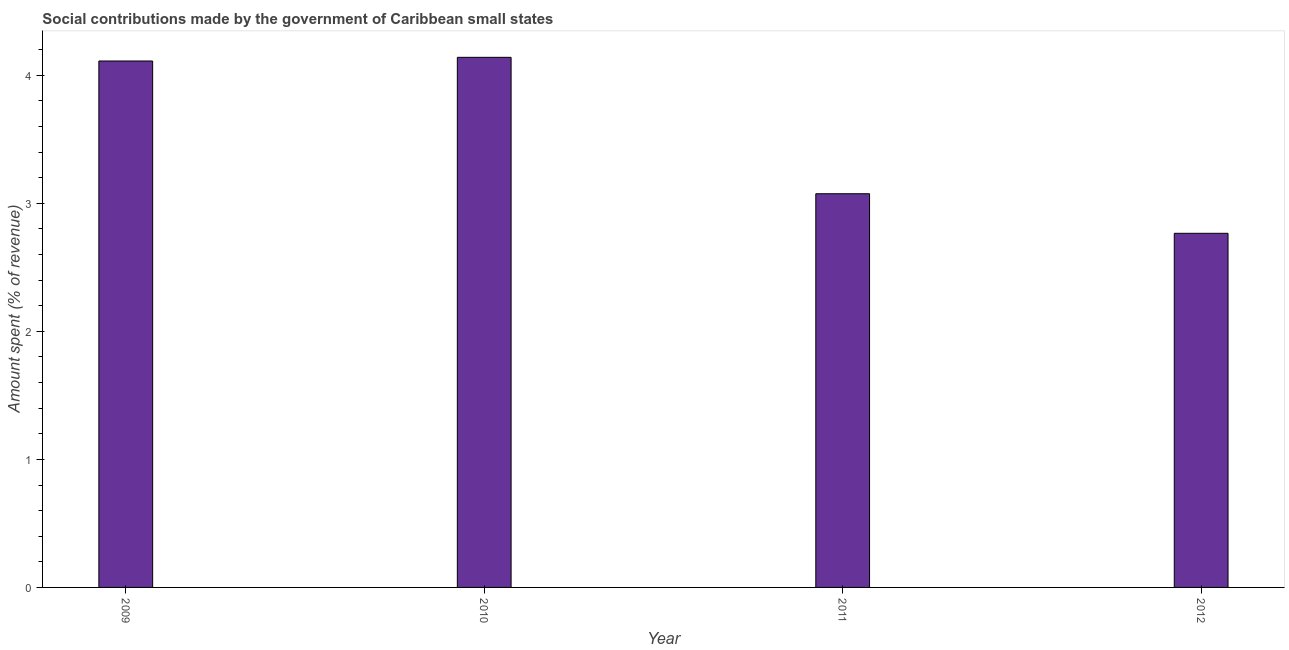Does the graph contain any zero values?
Provide a short and direct response. No. What is the title of the graph?
Ensure brevity in your answer.  Social contributions made by the government of Caribbean small states. What is the label or title of the Y-axis?
Give a very brief answer. Amount spent (% of revenue). What is the amount spent in making social contributions in 2009?
Your response must be concise. 4.11. Across all years, what is the maximum amount spent in making social contributions?
Keep it short and to the point. 4.14. Across all years, what is the minimum amount spent in making social contributions?
Offer a terse response. 2.77. In which year was the amount spent in making social contributions minimum?
Your answer should be very brief. 2012. What is the sum of the amount spent in making social contributions?
Keep it short and to the point. 14.09. What is the difference between the amount spent in making social contributions in 2009 and 2012?
Your answer should be compact. 1.35. What is the average amount spent in making social contributions per year?
Make the answer very short. 3.52. What is the median amount spent in making social contributions?
Provide a succinct answer. 3.59. In how many years, is the amount spent in making social contributions greater than 3.8 %?
Keep it short and to the point. 2. Do a majority of the years between 2011 and 2010 (inclusive) have amount spent in making social contributions greater than 1.4 %?
Make the answer very short. No. What is the ratio of the amount spent in making social contributions in 2011 to that in 2012?
Provide a succinct answer. 1.11. What is the difference between the highest and the second highest amount spent in making social contributions?
Offer a terse response. 0.03. What is the difference between the highest and the lowest amount spent in making social contributions?
Your answer should be very brief. 1.37. How many bars are there?
Offer a very short reply. 4. How many years are there in the graph?
Make the answer very short. 4. What is the difference between two consecutive major ticks on the Y-axis?
Provide a short and direct response. 1. Are the values on the major ticks of Y-axis written in scientific E-notation?
Your response must be concise. No. What is the Amount spent (% of revenue) in 2009?
Your response must be concise. 4.11. What is the Amount spent (% of revenue) in 2010?
Offer a very short reply. 4.14. What is the Amount spent (% of revenue) in 2011?
Your answer should be compact. 3.08. What is the Amount spent (% of revenue) in 2012?
Give a very brief answer. 2.77. What is the difference between the Amount spent (% of revenue) in 2009 and 2010?
Give a very brief answer. -0.03. What is the difference between the Amount spent (% of revenue) in 2009 and 2011?
Provide a succinct answer. 1.04. What is the difference between the Amount spent (% of revenue) in 2009 and 2012?
Provide a short and direct response. 1.35. What is the difference between the Amount spent (% of revenue) in 2010 and 2011?
Your response must be concise. 1.07. What is the difference between the Amount spent (% of revenue) in 2010 and 2012?
Provide a short and direct response. 1.37. What is the difference between the Amount spent (% of revenue) in 2011 and 2012?
Give a very brief answer. 0.31. What is the ratio of the Amount spent (% of revenue) in 2009 to that in 2010?
Your answer should be very brief. 0.99. What is the ratio of the Amount spent (% of revenue) in 2009 to that in 2011?
Your response must be concise. 1.34. What is the ratio of the Amount spent (% of revenue) in 2009 to that in 2012?
Provide a short and direct response. 1.49. What is the ratio of the Amount spent (% of revenue) in 2010 to that in 2011?
Your answer should be compact. 1.35. What is the ratio of the Amount spent (% of revenue) in 2010 to that in 2012?
Ensure brevity in your answer.  1.5. What is the ratio of the Amount spent (% of revenue) in 2011 to that in 2012?
Offer a very short reply. 1.11. 